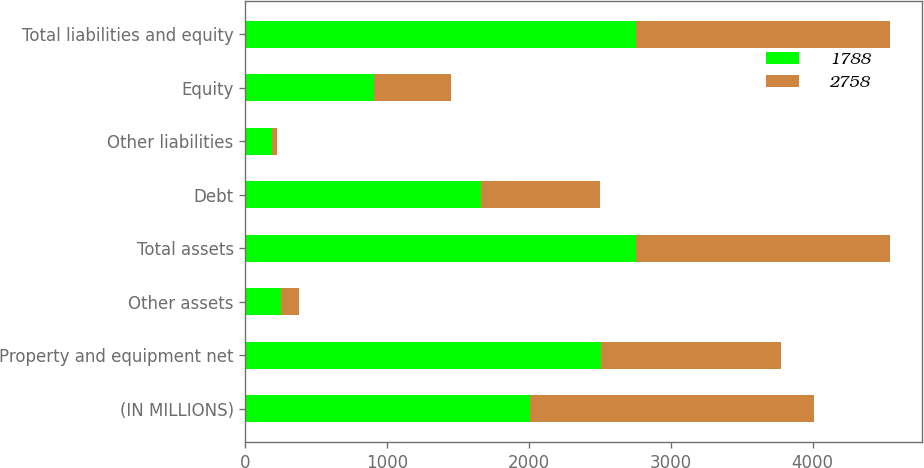<chart> <loc_0><loc_0><loc_500><loc_500><stacked_bar_chart><ecel><fcel>(IN MILLIONS)<fcel>Property and equipment net<fcel>Other assets<fcel>Total assets<fcel>Debt<fcel>Other liabilities<fcel>Equity<fcel>Total liabilities and equity<nl><fcel>1788<fcel>2006<fcel>2508<fcel>250<fcel>2758<fcel>1660<fcel>191<fcel>907<fcel>2758<nl><fcel>2758<fcel>2005<fcel>1270<fcel>131<fcel>1788<fcel>841<fcel>31<fcel>546<fcel>1788<nl></chart> 